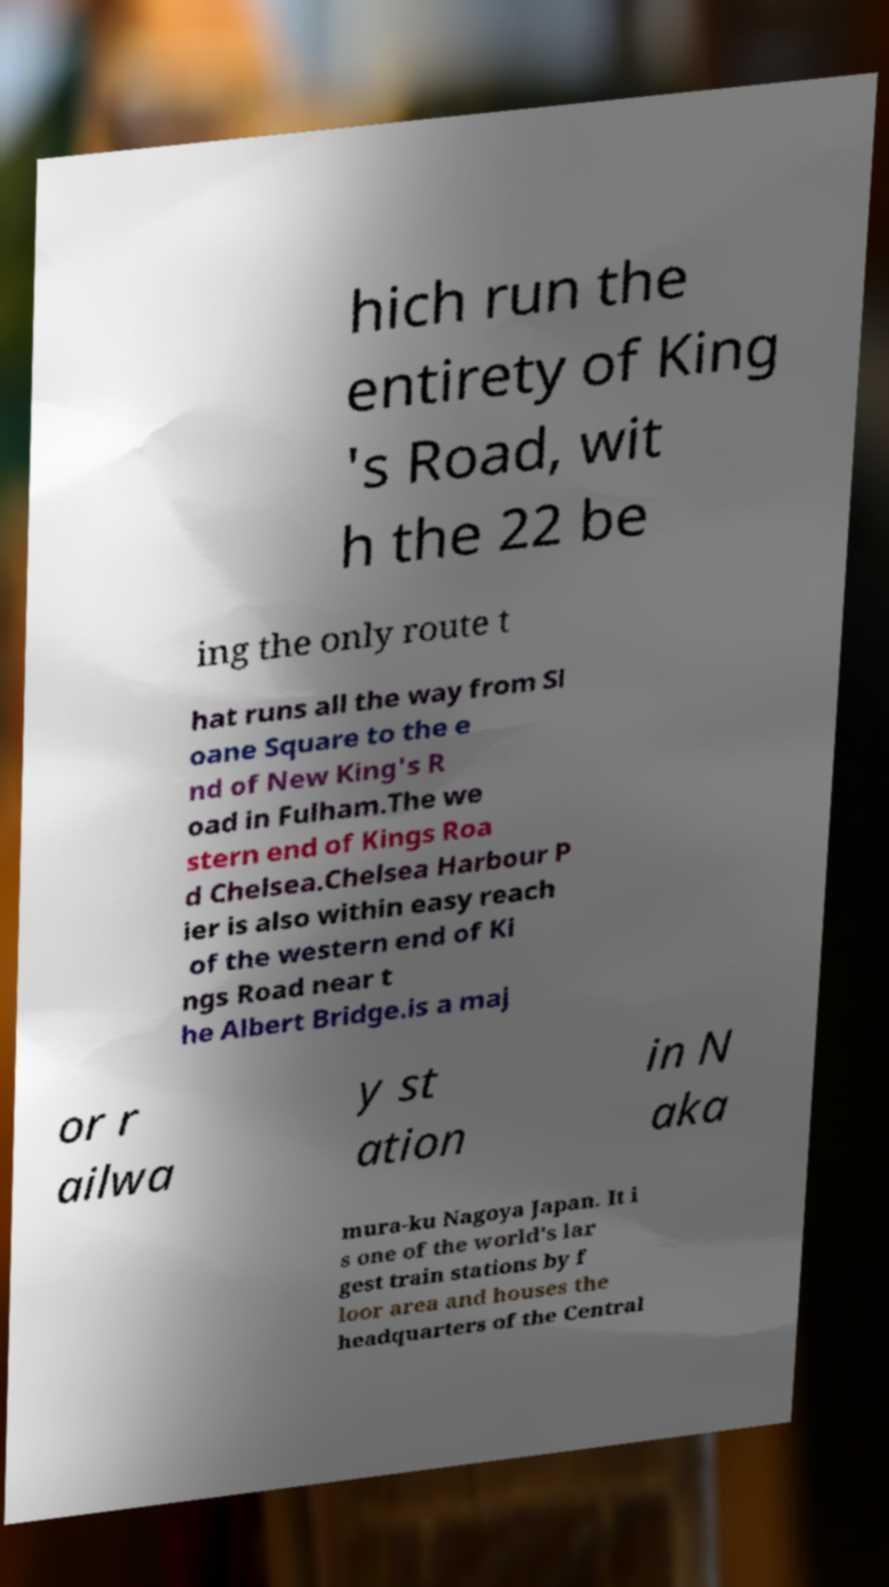Please read and relay the text visible in this image. What does it say? hich run the entirety of King 's Road, wit h the 22 be ing the only route t hat runs all the way from Sl oane Square to the e nd of New King's R oad in Fulham.The we stern end of Kings Roa d Chelsea.Chelsea Harbour P ier is also within easy reach of the western end of Ki ngs Road near t he Albert Bridge.is a maj or r ailwa y st ation in N aka mura-ku Nagoya Japan. It i s one of the world's lar gest train stations by f loor area and houses the headquarters of the Central 